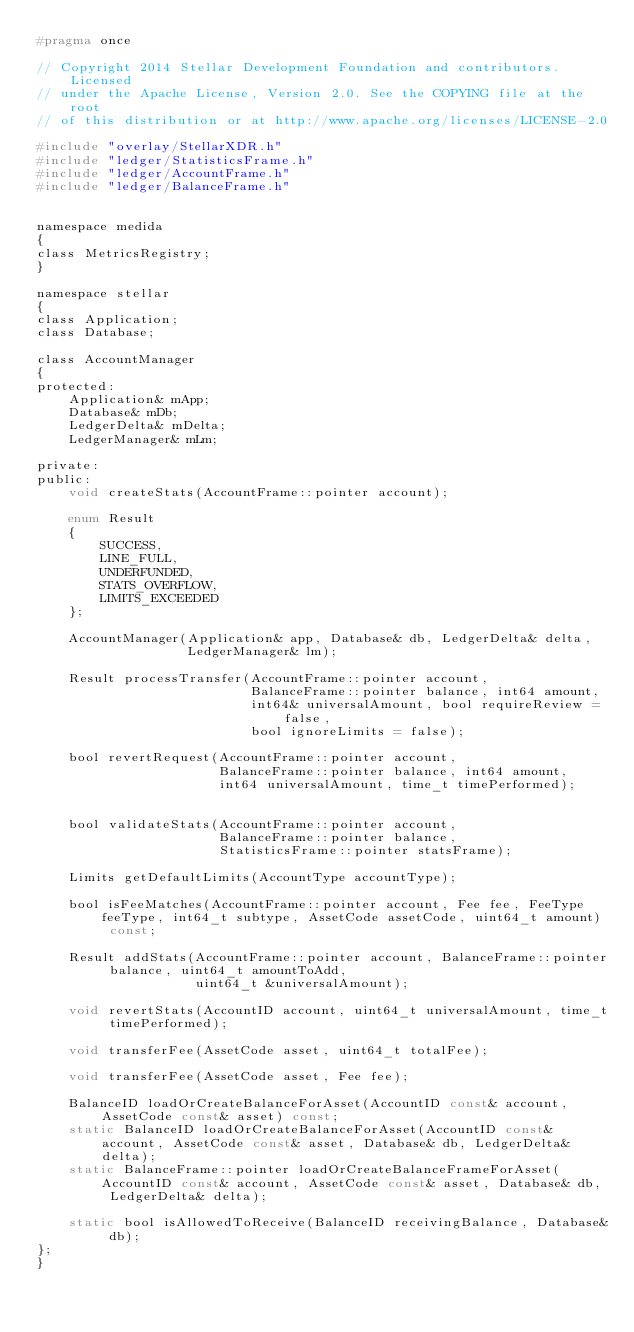<code> <loc_0><loc_0><loc_500><loc_500><_C_>#pragma once

// Copyright 2014 Stellar Development Foundation and contributors. Licensed
// under the Apache License, Version 2.0. See the COPYING file at the root
// of this distribution or at http://www.apache.org/licenses/LICENSE-2.0

#include "overlay/StellarXDR.h"
#include "ledger/StatisticsFrame.h"
#include "ledger/AccountFrame.h"
#include "ledger/BalanceFrame.h"


namespace medida
{
class MetricsRegistry;
}

namespace stellar
{
class Application;
class Database;

class AccountManager
{
protected:
    Application& mApp;
    Database& mDb;
    LedgerDelta& mDelta;
    LedgerManager& mLm;

private:
public:
    void createStats(AccountFrame::pointer account);

    enum Result
    {
        SUCCESS,
        LINE_FULL,
        UNDERFUNDED,
        STATS_OVERFLOW,
        LIMITS_EXCEEDED
    };

    AccountManager(Application& app, Database& db, LedgerDelta& delta,
                   LedgerManager& lm);

    Result processTransfer(AccountFrame::pointer account,
                           BalanceFrame::pointer balance, int64 amount,
                           int64& universalAmount, bool requireReview = false,
                           bool ignoreLimits = false);

    bool revertRequest(AccountFrame::pointer account,
                       BalanceFrame::pointer balance, int64 amount,
                       int64 universalAmount, time_t timePerformed);


    bool validateStats(AccountFrame::pointer account,
                       BalanceFrame::pointer balance,
                       StatisticsFrame::pointer statsFrame);

    Limits getDefaultLimits(AccountType accountType);

    bool isFeeMatches(AccountFrame::pointer account, Fee fee, FeeType feeType, int64_t subtype, AssetCode assetCode, uint64_t amount) const;

    Result addStats(AccountFrame::pointer account, BalanceFrame::pointer balance, uint64_t amountToAdd,
                    uint64_t &universalAmount);

    void revertStats(AccountID account, uint64_t universalAmount, time_t timePerformed);

    void transferFee(AssetCode asset, uint64_t totalFee);

    void transferFee(AssetCode asset, Fee fee);

    BalanceID loadOrCreateBalanceForAsset(AccountID const& account, AssetCode const& asset) const;
    static BalanceID loadOrCreateBalanceForAsset(AccountID const& account, AssetCode const& asset, Database& db, LedgerDelta& delta);
    static BalanceFrame::pointer loadOrCreateBalanceFrameForAsset(AccountID const& account, AssetCode const& asset, Database& db, LedgerDelta& delta);

    static bool isAllowedToReceive(BalanceID receivingBalance, Database& db);
};
}
</code> 